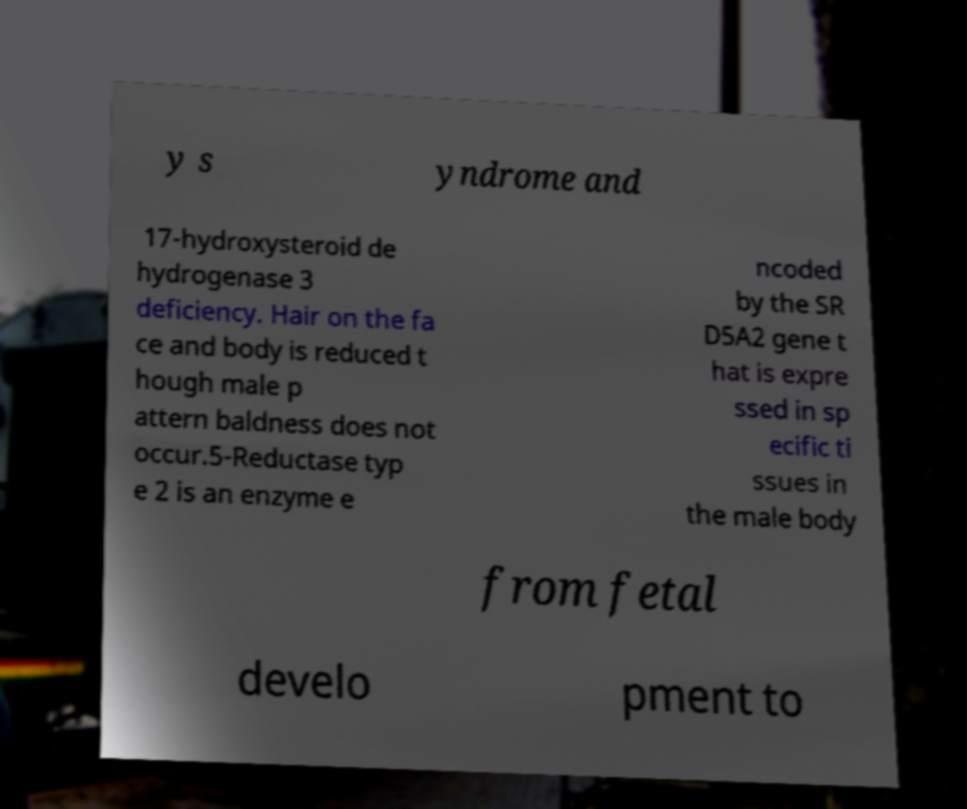Can you accurately transcribe the text from the provided image for me? y s yndrome and 17-hydroxysteroid de hydrogenase 3 deficiency. Hair on the fa ce and body is reduced t hough male p attern baldness does not occur.5-Reductase typ e 2 is an enzyme e ncoded by the SR D5A2 gene t hat is expre ssed in sp ecific ti ssues in the male body from fetal develo pment to 